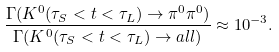Convert formula to latex. <formula><loc_0><loc_0><loc_500><loc_500>\frac { \Gamma ( K ^ { 0 } ( \tau _ { S } < t < \tau _ { L } ) \rightarrow \pi ^ { 0 } \pi ^ { 0 } ) } { \Gamma ( K ^ { 0 } ( \tau _ { S } < t < \tau _ { L } ) \rightarrow a l l ) } \approx 1 0 ^ { - 3 } .</formula> 